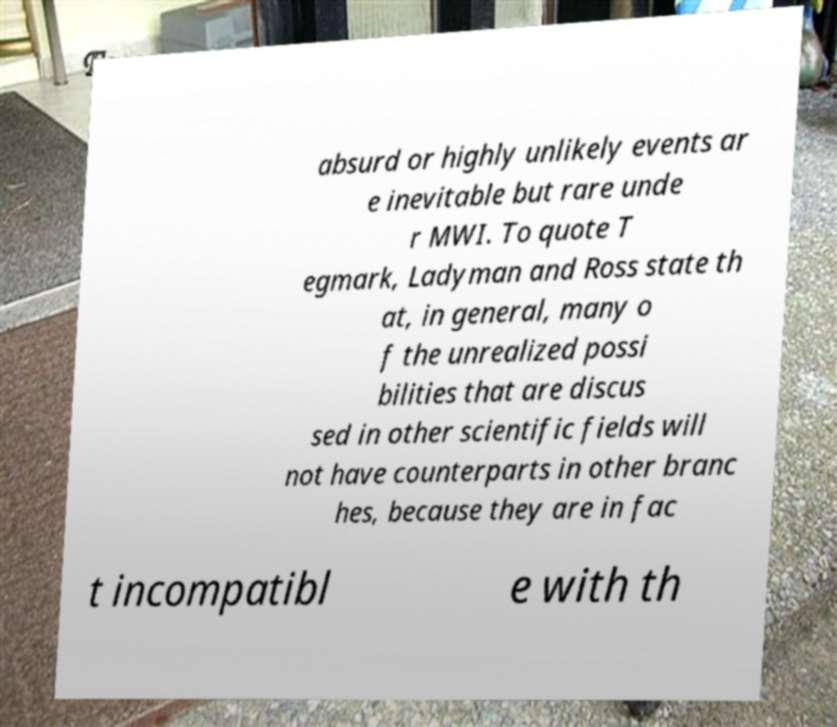There's text embedded in this image that I need extracted. Can you transcribe it verbatim? absurd or highly unlikely events ar e inevitable but rare unde r MWI. To quote T egmark, Ladyman and Ross state th at, in general, many o f the unrealized possi bilities that are discus sed in other scientific fields will not have counterparts in other branc hes, because they are in fac t incompatibl e with th 